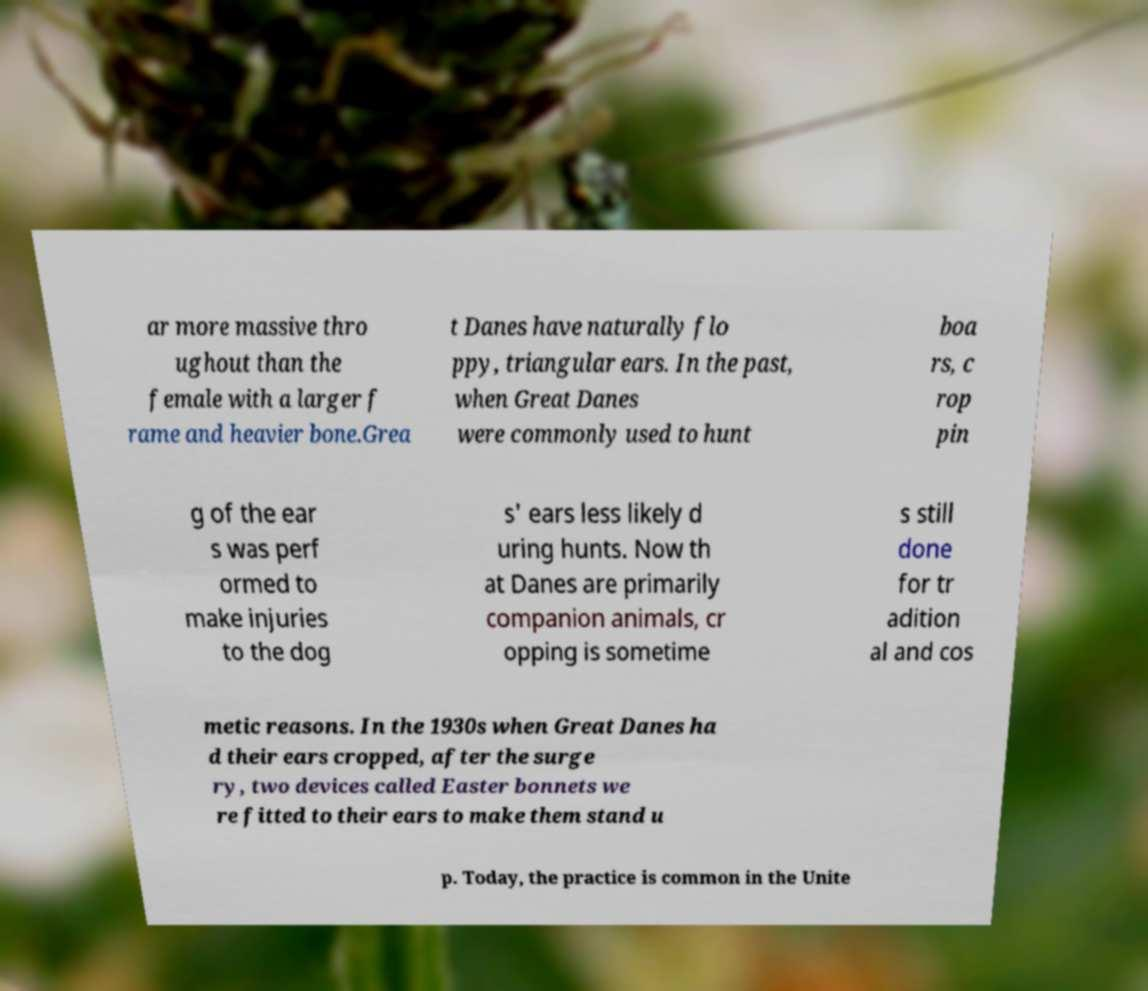What messages or text are displayed in this image? I need them in a readable, typed format. ar more massive thro ughout than the female with a larger f rame and heavier bone.Grea t Danes have naturally flo ppy, triangular ears. In the past, when Great Danes were commonly used to hunt boa rs, c rop pin g of the ear s was perf ormed to make injuries to the dog s' ears less likely d uring hunts. Now th at Danes are primarily companion animals, cr opping is sometime s still done for tr adition al and cos metic reasons. In the 1930s when Great Danes ha d their ears cropped, after the surge ry, two devices called Easter bonnets we re fitted to their ears to make them stand u p. Today, the practice is common in the Unite 